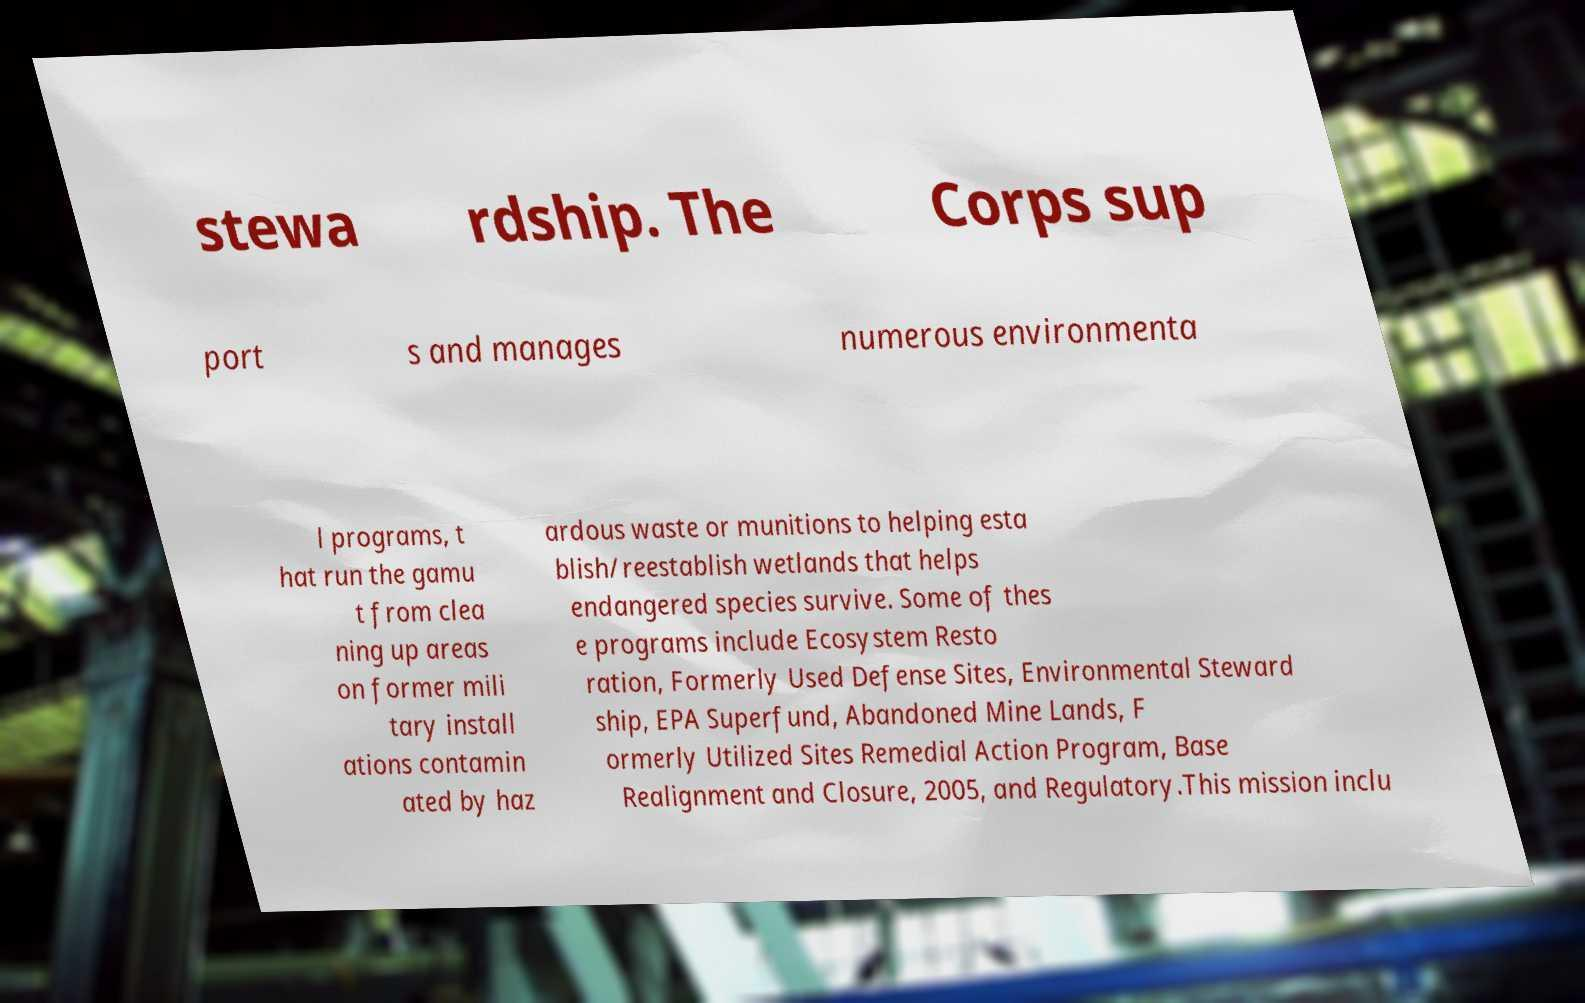Could you extract and type out the text from this image? stewa rdship. The Corps sup port s and manages numerous environmenta l programs, t hat run the gamu t from clea ning up areas on former mili tary install ations contamin ated by haz ardous waste or munitions to helping esta blish/reestablish wetlands that helps endangered species survive. Some of thes e programs include Ecosystem Resto ration, Formerly Used Defense Sites, Environmental Steward ship, EPA Superfund, Abandoned Mine Lands, F ormerly Utilized Sites Remedial Action Program, Base Realignment and Closure, 2005, and Regulatory.This mission inclu 